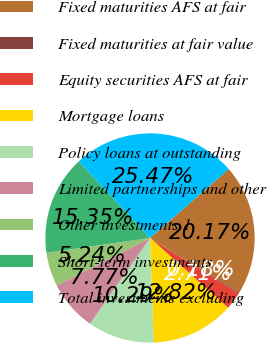Convert chart to OTSL. <chart><loc_0><loc_0><loc_500><loc_500><pie_chart><fcel>Fixed maturities AFS at fair<fcel>Fixed maturities at fair value<fcel>Equity securities AFS at fair<fcel>Mortgage loans<fcel>Policy loans at outstanding<fcel>Limited partnerships and other<fcel>Other investments 1<fcel>Short-term investments<fcel>Total investments excluding<nl><fcel>20.17%<fcel>0.18%<fcel>2.71%<fcel>12.82%<fcel>10.29%<fcel>7.77%<fcel>5.24%<fcel>15.35%<fcel>25.47%<nl></chart> 